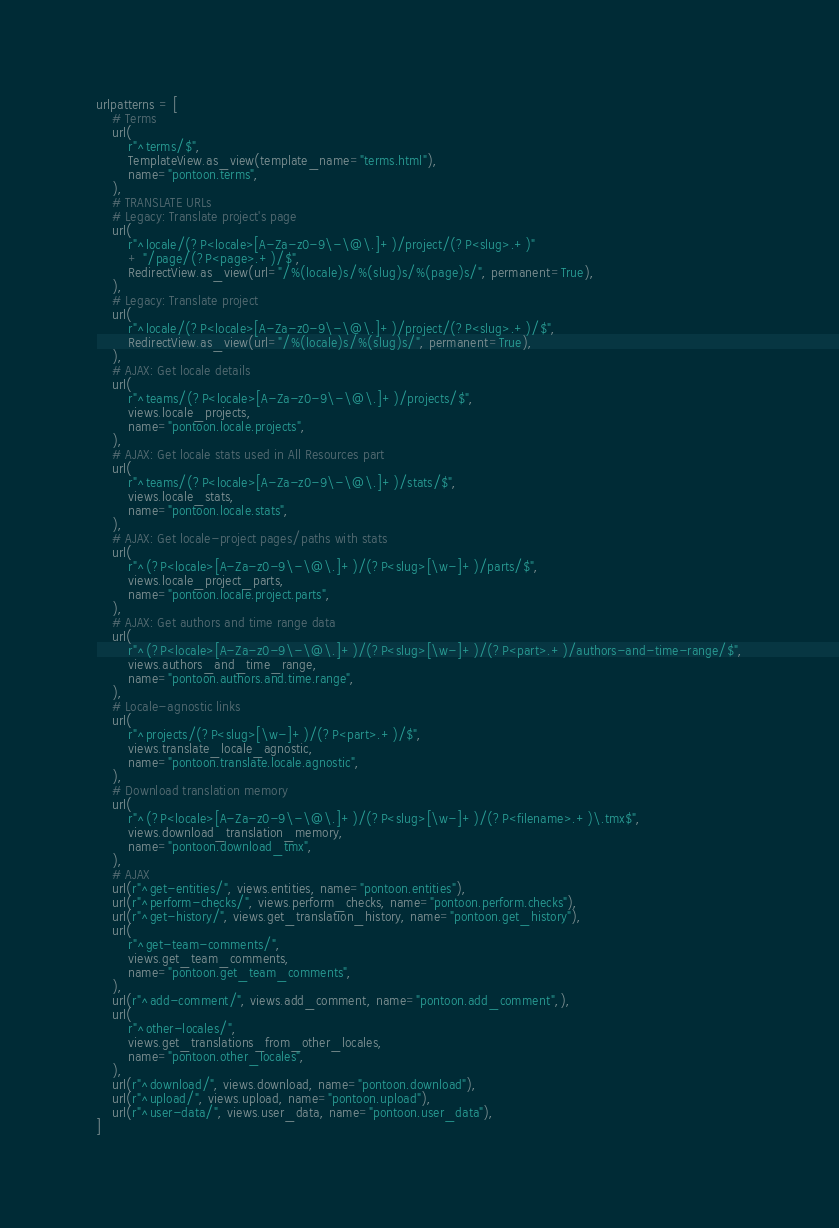<code> <loc_0><loc_0><loc_500><loc_500><_Python_>
urlpatterns = [
    # Terms
    url(
        r"^terms/$",
        TemplateView.as_view(template_name="terms.html"),
        name="pontoon.terms",
    ),
    # TRANSLATE URLs
    # Legacy: Translate project's page
    url(
        r"^locale/(?P<locale>[A-Za-z0-9\-\@\.]+)/project/(?P<slug>.+)"
        + "/page/(?P<page>.+)/$",
        RedirectView.as_view(url="/%(locale)s/%(slug)s/%(page)s/", permanent=True),
    ),
    # Legacy: Translate project
    url(
        r"^locale/(?P<locale>[A-Za-z0-9\-\@\.]+)/project/(?P<slug>.+)/$",
        RedirectView.as_view(url="/%(locale)s/%(slug)s/", permanent=True),
    ),
    # AJAX: Get locale details
    url(
        r"^teams/(?P<locale>[A-Za-z0-9\-\@\.]+)/projects/$",
        views.locale_projects,
        name="pontoon.locale.projects",
    ),
    # AJAX: Get locale stats used in All Resources part
    url(
        r"^teams/(?P<locale>[A-Za-z0-9\-\@\.]+)/stats/$",
        views.locale_stats,
        name="pontoon.locale.stats",
    ),
    # AJAX: Get locale-project pages/paths with stats
    url(
        r"^(?P<locale>[A-Za-z0-9\-\@\.]+)/(?P<slug>[\w-]+)/parts/$",
        views.locale_project_parts,
        name="pontoon.locale.project.parts",
    ),
    # AJAX: Get authors and time range data
    url(
        r"^(?P<locale>[A-Za-z0-9\-\@\.]+)/(?P<slug>[\w-]+)/(?P<part>.+)/authors-and-time-range/$",
        views.authors_and_time_range,
        name="pontoon.authors.and.time.range",
    ),
    # Locale-agnostic links
    url(
        r"^projects/(?P<slug>[\w-]+)/(?P<part>.+)/$",
        views.translate_locale_agnostic,
        name="pontoon.translate.locale.agnostic",
    ),
    # Download translation memory
    url(
        r"^(?P<locale>[A-Za-z0-9\-\@\.]+)/(?P<slug>[\w-]+)/(?P<filename>.+)\.tmx$",
        views.download_translation_memory,
        name="pontoon.download_tmx",
    ),
    # AJAX
    url(r"^get-entities/", views.entities, name="pontoon.entities"),
    url(r"^perform-checks/", views.perform_checks, name="pontoon.perform.checks"),
    url(r"^get-history/", views.get_translation_history, name="pontoon.get_history"),
    url(
        r"^get-team-comments/",
        views.get_team_comments,
        name="pontoon.get_team_comments",
    ),
    url(r"^add-comment/", views.add_comment, name="pontoon.add_comment",),
    url(
        r"^other-locales/",
        views.get_translations_from_other_locales,
        name="pontoon.other_locales",
    ),
    url(r"^download/", views.download, name="pontoon.download"),
    url(r"^upload/", views.upload, name="pontoon.upload"),
    url(r"^user-data/", views.user_data, name="pontoon.user_data"),
]
</code> 